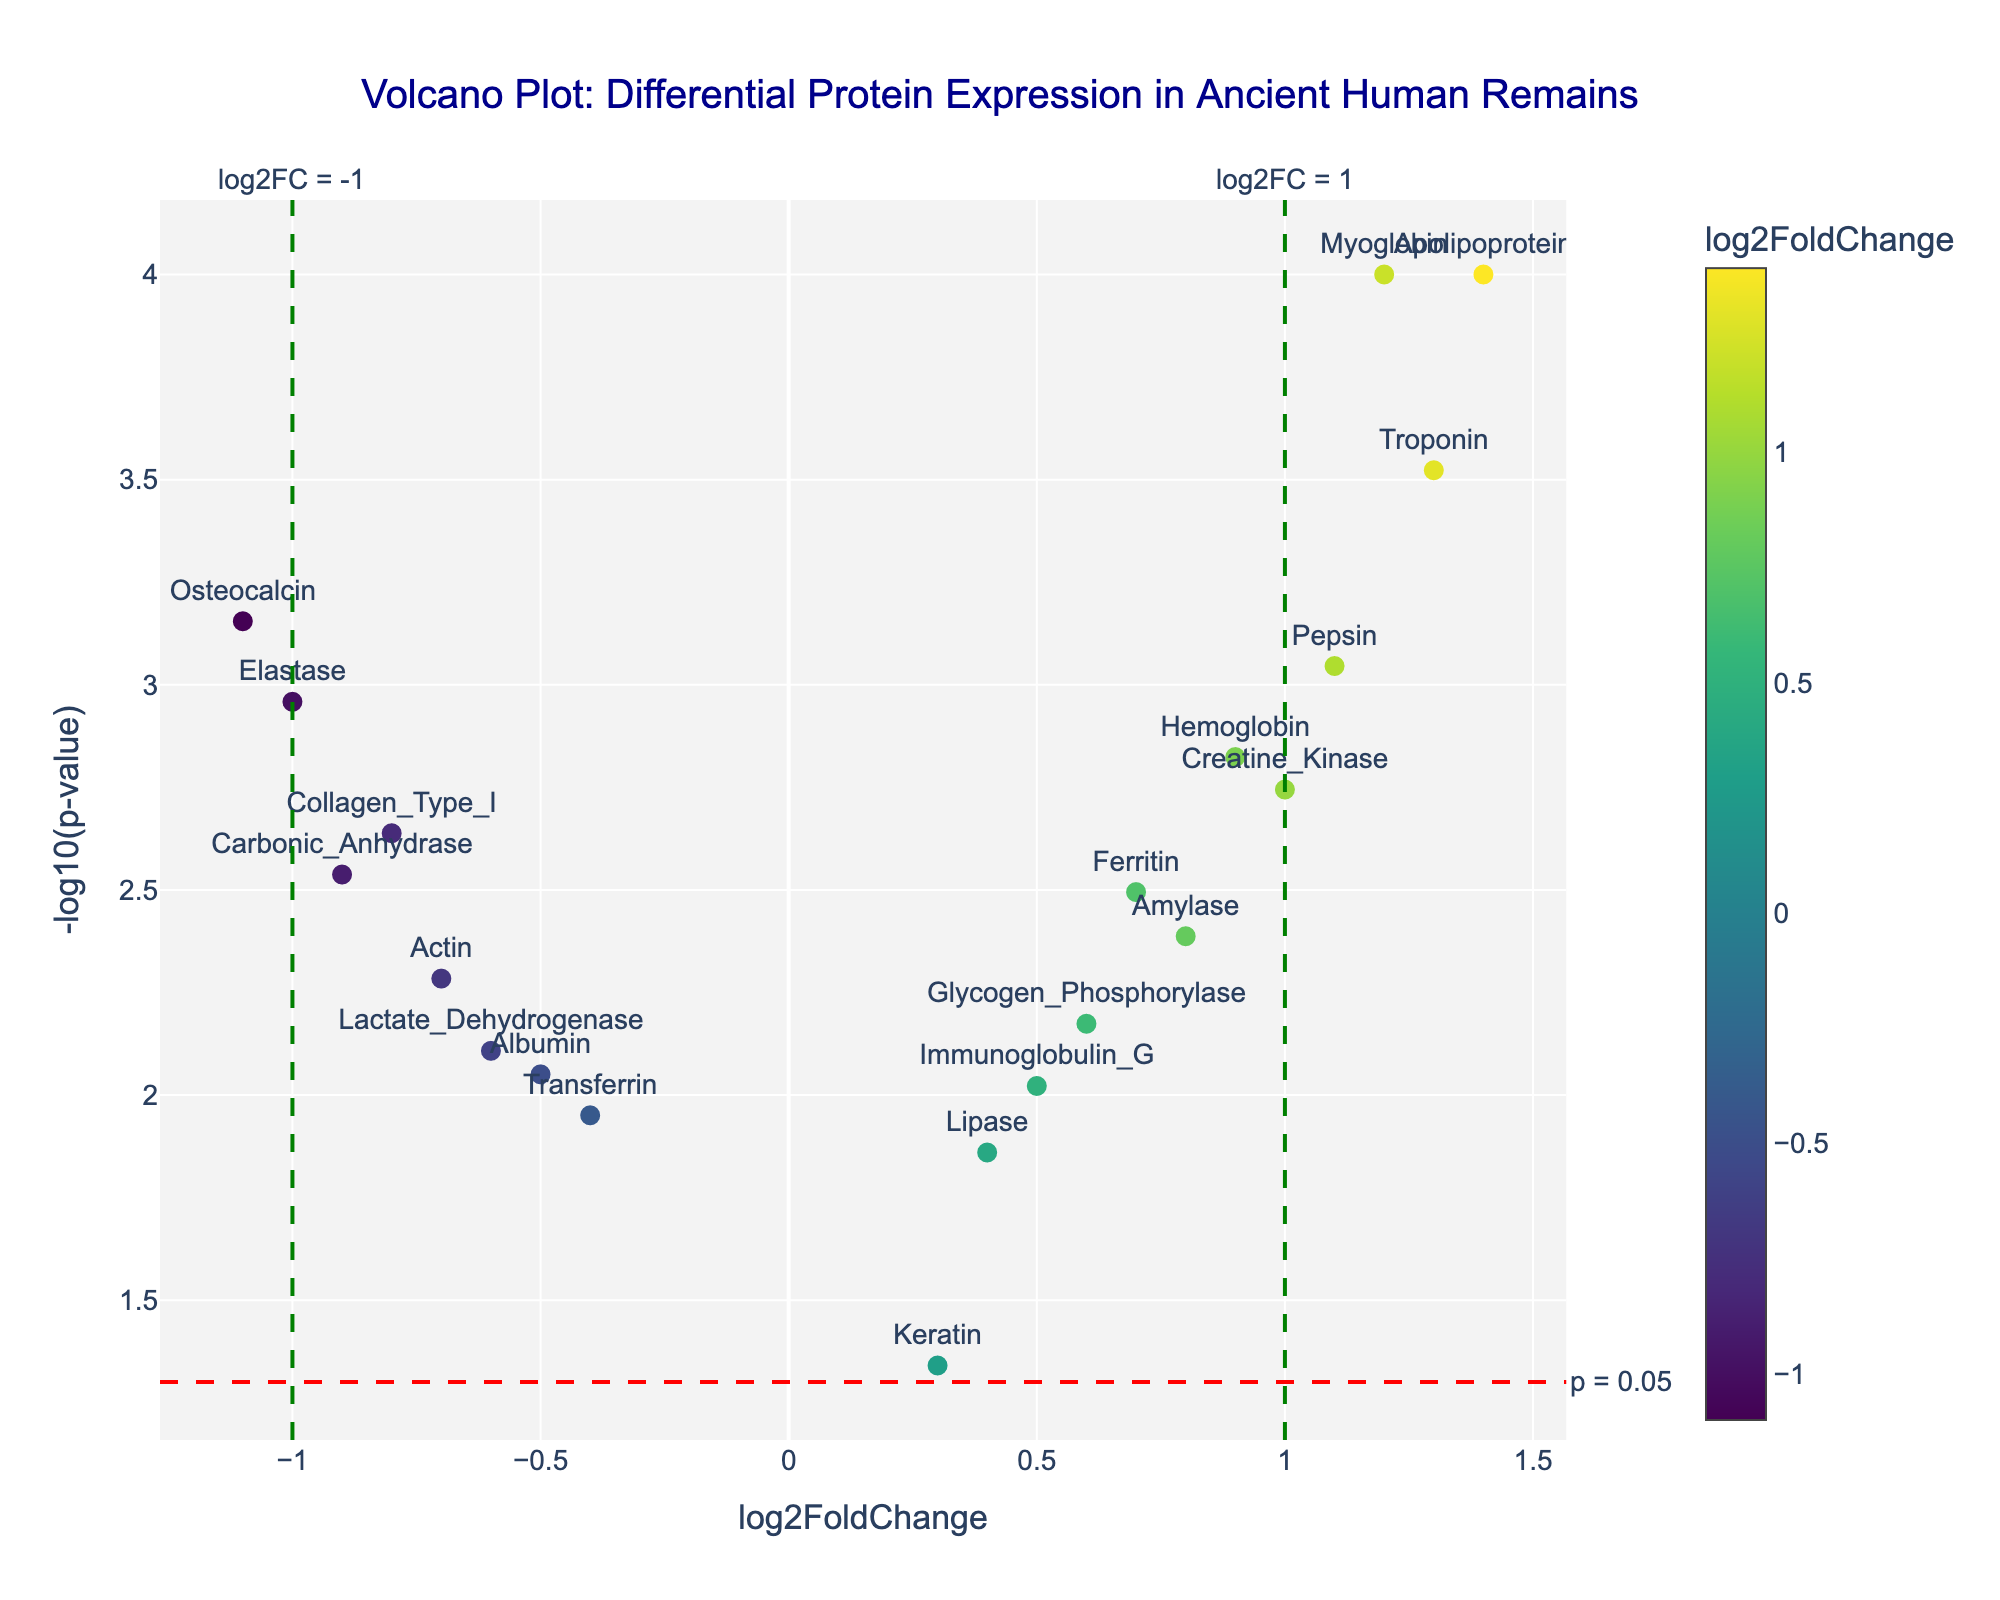How many proteins are presented in the volcano plot? Count the number of data points representing proteins in the plot. There are 18 proteins listed in the dataset
Answer: 18 What is the title of the volcano plot? Identify the main heading or title text on the figure. The title is "Volcano Plot: Differential Protein Expression in Ancient Human Remains"
Answer: Volcano Plot: Differential Protein Expression in Ancient Human Remains Which protein shows the highest log2FoldChange value? Look at the x-axis values and find the protein with the highest positive value. Apolipoprotein has a log2FoldChange value of 1.4
Answer: Apolipoprotein Which protein has the lowest p-value? The lowest p-value corresponds to the highest -log10(p-value). Myoglobin has the highest -log10(p-value) value, corresponding to the lowest p-value of 0.0001
Answer: Myoglobin How many proteins are associated with a negative log2FoldChange? Count the data points to the left of the x-axis where log2FoldChange is negative. There are 8 proteins with negative log2FoldChange values
Answer: 8 What is the color scale used for in the plot? Identify what the colors of the data points represent. The colors indicate log2FoldChange values, with a colorbar showing the gradient
Answer: log2FoldChange Which protein is closest to the p-value threshold line of 0.05? Identify the data point closest to the horizontal dashed red line. Keratin, with a p-value of 0.0456, is closest to the threshold of 0.05
Answer: Keratin Are there more proteins with a log2FoldChange greater than 1 or less than -1? Compare the number of data points to the right of log2FC=1 with those left of log2FC=-1. There are 3 proteins with log2FoldChange > 1 and 4 proteins with log2FoldChange < -1
Answer: log2FoldChange less than -1 What is the difference in -log10(p-value) between the proteins with the highest and lowest p-values? The highest -log10(p-value) is for Myoglobin (4), and the lowest is for Keratin (~1.34). The difference is 4 - 1.34
Answer: 2.66 How many proteins have a p-value below 0.05? Count the data points above the horizontal red line at -log10(p-value) = -log10(0.05), which equals approximately 1.3. There are 13 proteins above this line
Answer: 13 